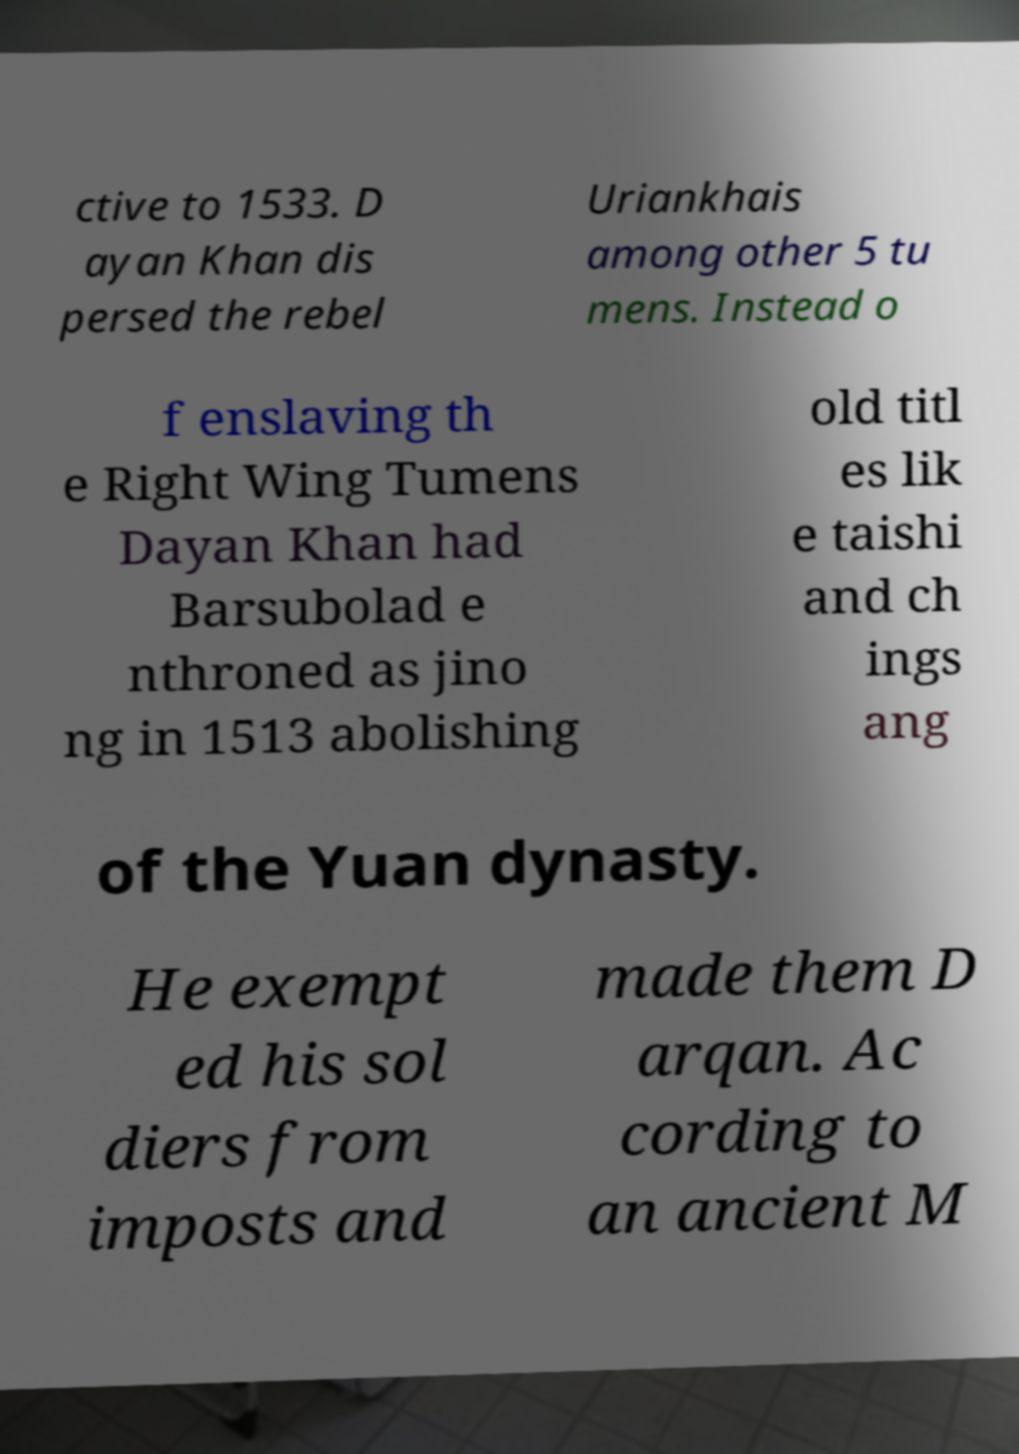Please identify and transcribe the text found in this image. ctive to 1533. D ayan Khan dis persed the rebel Uriankhais among other 5 tu mens. Instead o f enslaving th e Right Wing Tumens Dayan Khan had Barsubolad e nthroned as jino ng in 1513 abolishing old titl es lik e taishi and ch ings ang of the Yuan dynasty. He exempt ed his sol diers from imposts and made them D arqan. Ac cording to an ancient M 